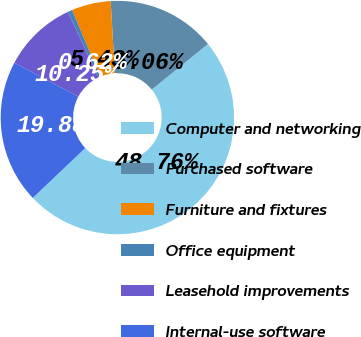Convert chart to OTSL. <chart><loc_0><loc_0><loc_500><loc_500><pie_chart><fcel>Computer and networking<fcel>Purchased software<fcel>Furniture and fixtures<fcel>Office equipment<fcel>Leasehold improvements<fcel>Internal-use software<nl><fcel>48.76%<fcel>15.06%<fcel>5.43%<fcel>0.62%<fcel>10.25%<fcel>19.88%<nl></chart> 